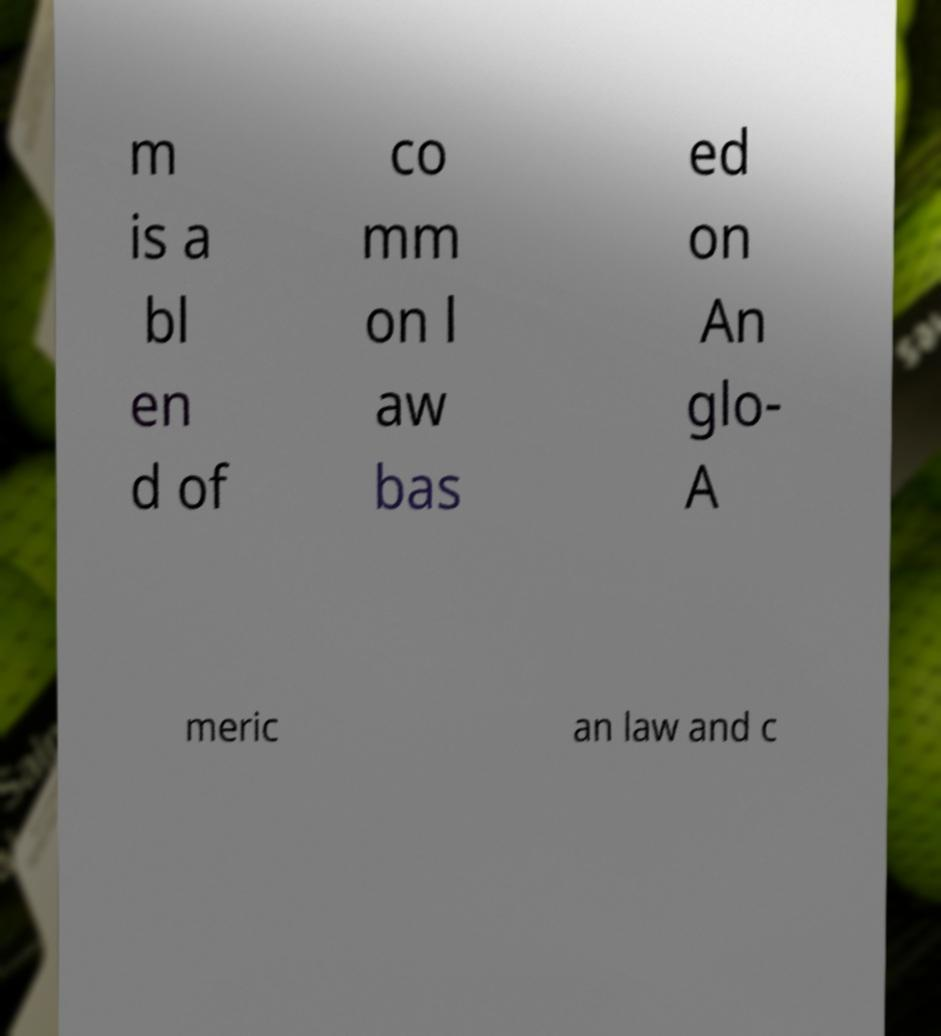Could you assist in decoding the text presented in this image and type it out clearly? m is a bl en d of co mm on l aw bas ed on An glo- A meric an law and c 